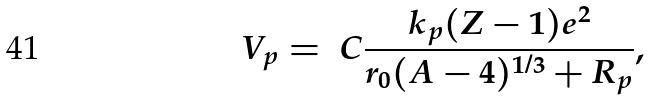<formula> <loc_0><loc_0><loc_500><loc_500>V _ { p } = \ C \frac { k _ { p } ( Z - 1 ) e ^ { 2 } } { r _ { 0 } ( A - 4 ) ^ { 1 / 3 } + R _ { p } } ,</formula> 